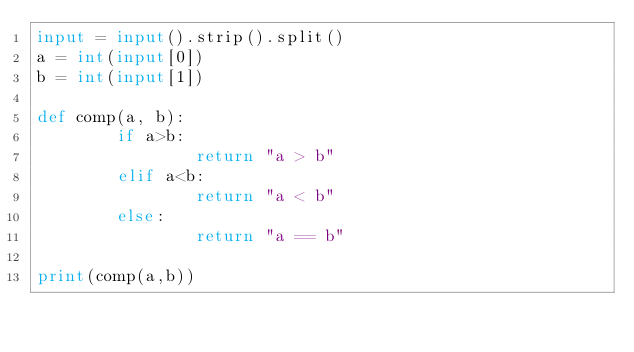<code> <loc_0><loc_0><loc_500><loc_500><_Python_>input = input().strip().split()
a = int(input[0])
b = int(input[1])

def comp(a, b):
        if a>b:
                return "a > b"
        elif a<b:
                return "a < b"
        else:
                return "a == b"

print(comp(a,b))</code> 